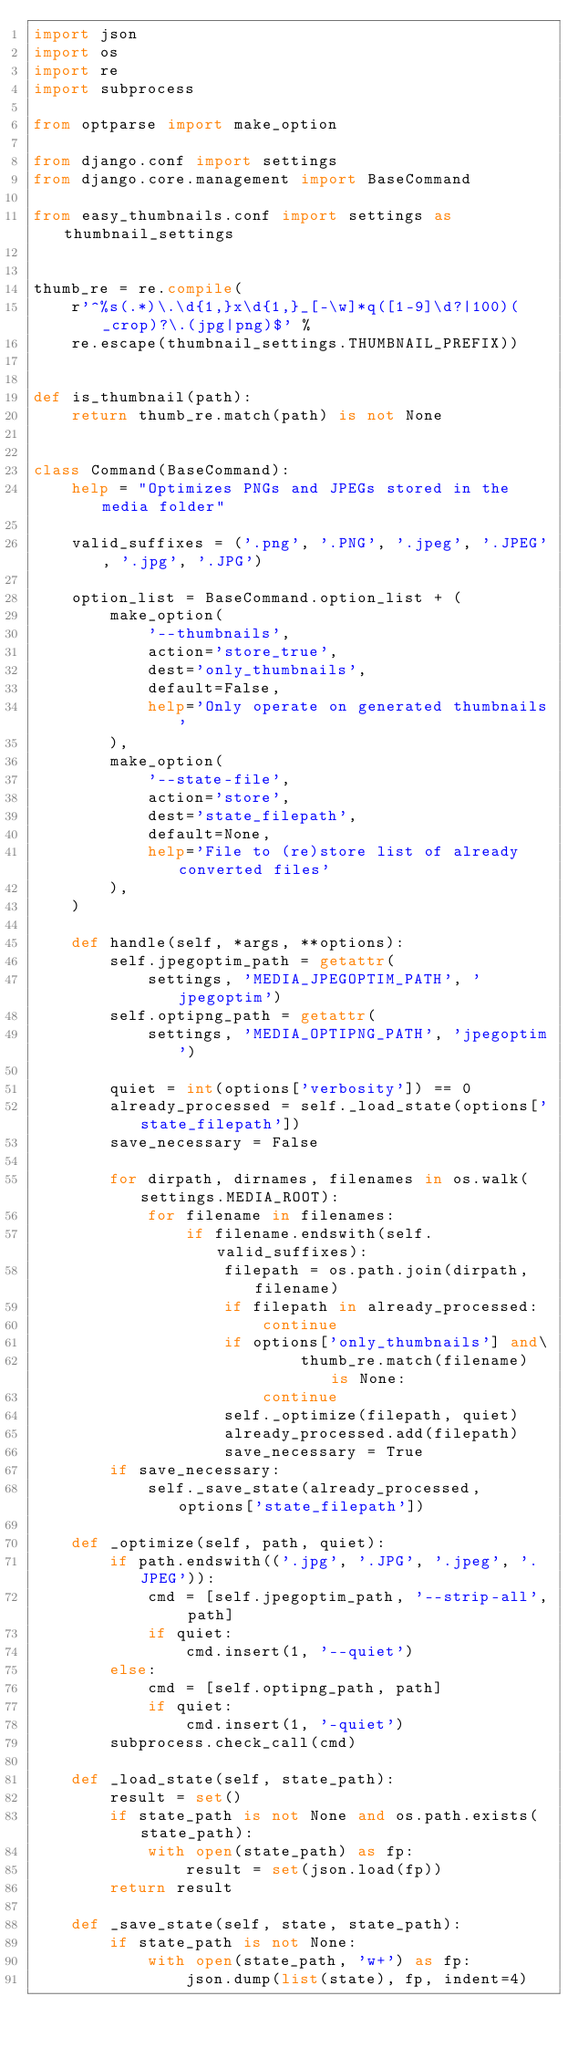<code> <loc_0><loc_0><loc_500><loc_500><_Python_>import json
import os
import re
import subprocess

from optparse import make_option

from django.conf import settings
from django.core.management import BaseCommand

from easy_thumbnails.conf import settings as thumbnail_settings


thumb_re = re.compile(
    r'^%s(.*)\.\d{1,}x\d{1,}_[-\w]*q([1-9]\d?|100)(_crop)?\.(jpg|png)$' %
    re.escape(thumbnail_settings.THUMBNAIL_PREFIX))


def is_thumbnail(path):
    return thumb_re.match(path) is not None


class Command(BaseCommand):
    help = "Optimizes PNGs and JPEGs stored in the media folder"

    valid_suffixes = ('.png', '.PNG', '.jpeg', '.JPEG', '.jpg', '.JPG')

    option_list = BaseCommand.option_list + (
        make_option(
            '--thumbnails',
            action='store_true',
            dest='only_thumbnails',
            default=False,
            help='Only operate on generated thumbnails'
        ),
        make_option(
            '--state-file',
            action='store',
            dest='state_filepath',
            default=None,
            help='File to (re)store list of already converted files'
        ),
    )

    def handle(self, *args, **options):
        self.jpegoptim_path = getattr(
            settings, 'MEDIA_JPEGOPTIM_PATH', 'jpegoptim')
        self.optipng_path = getattr(
            settings, 'MEDIA_OPTIPNG_PATH', 'jpegoptim')

        quiet = int(options['verbosity']) == 0
        already_processed = self._load_state(options['state_filepath'])
        save_necessary = False

        for dirpath, dirnames, filenames in os.walk(settings.MEDIA_ROOT):
            for filename in filenames:
                if filename.endswith(self.valid_suffixes):
                    filepath = os.path.join(dirpath, filename)
                    if filepath in already_processed:
                        continue
                    if options['only_thumbnails'] and\
                            thumb_re.match(filename) is None:
                        continue
                    self._optimize(filepath, quiet)
                    already_processed.add(filepath)
                    save_necessary = True
        if save_necessary:
            self._save_state(already_processed, options['state_filepath'])

    def _optimize(self, path, quiet):
        if path.endswith(('.jpg', '.JPG', '.jpeg', '.JPEG')):
            cmd = [self.jpegoptim_path, '--strip-all', path]
            if quiet:
                cmd.insert(1, '--quiet')
        else:
            cmd = [self.optipng_path, path]
            if quiet:
                cmd.insert(1, '-quiet')
        subprocess.check_call(cmd)

    def _load_state(self, state_path):
        result = set()
        if state_path is not None and os.path.exists(state_path):
            with open(state_path) as fp:
                result = set(json.load(fp))
        return result

    def _save_state(self, state, state_path):
        if state_path is not None:
            with open(state_path, 'w+') as fp:
                json.dump(list(state), fp, indent=4)
</code> 